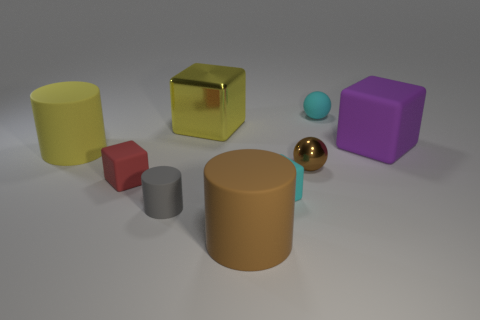Subtract all metal blocks. How many blocks are left? 3 Subtract all brown cylinders. How many cylinders are left? 2 Subtract 3 cylinders. How many cylinders are left? 0 Subtract all gray spheres. Subtract all green cubes. How many spheres are left? 2 Subtract all green blocks. How many purple spheres are left? 0 Subtract all gray matte cylinders. Subtract all big purple matte cubes. How many objects are left? 7 Add 5 big shiny things. How many big shiny things are left? 6 Add 1 matte balls. How many matte balls exist? 2 Subtract 1 gray cylinders. How many objects are left? 8 Subtract all blocks. How many objects are left? 5 